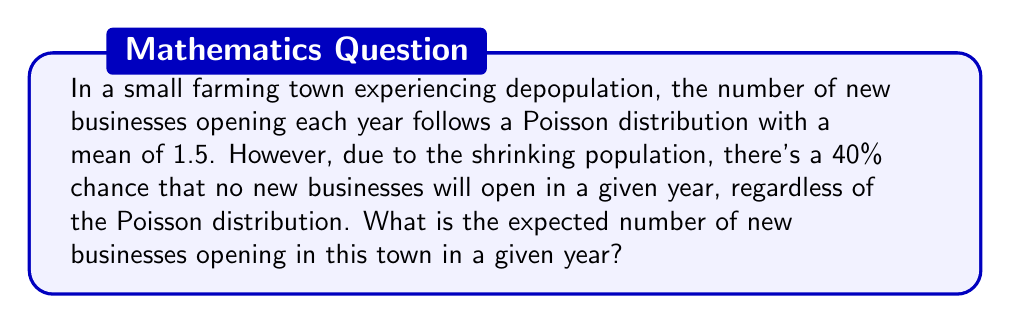Can you solve this math problem? Let's approach this step-by-step:

1) Let X be the random variable representing the number of new businesses opening in a year.

2) We have two scenarios:
   a) No businesses open (with probability 0.4)
   b) Businesses open according to a Poisson distribution (with probability 0.6)

3) Let's define Y as the Poisson-distributed random variable with mean λ = 1.5.

4) The probability mass function for Y is:

   $$P(Y=k) = \frac{e^{-\lambda}\lambda^k}{k!}$$

5) The expected value of Y is E(Y) = λ = 1.5

6) Now, we can express X as:

   $$X = \begin{cases} 
   0 & \text{with probability 0.4} \\
   Y & \text{with probability 0.6}
   \end{cases}$$

7) The expected value of X is:

   $$E(X) = 0.4 \cdot 0 + 0.6 \cdot E(Y)$$

8) Substituting E(Y) = 1.5:

   $$E(X) = 0.4 \cdot 0 + 0.6 \cdot 1.5 = 0.9$$

Therefore, the expected number of new businesses opening in a given year is 0.9.
Answer: 0.9 businesses 